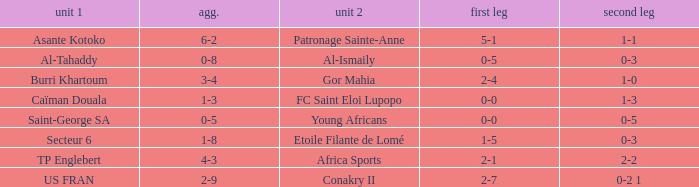Which teams achieved a combined score of 3-4? Burri Khartoum. 